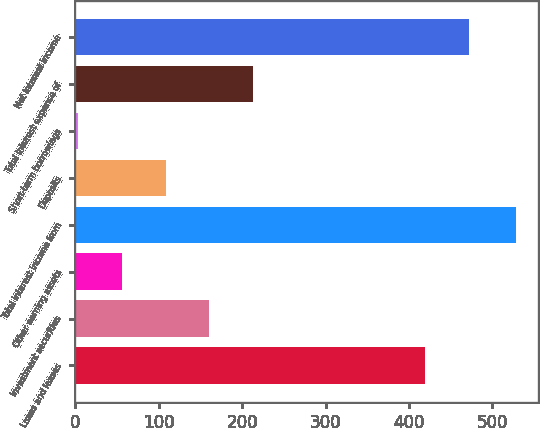<chart> <loc_0><loc_0><loc_500><loc_500><bar_chart><fcel>Loans and leases<fcel>Investment securities<fcel>Other earning assets<fcel>Total interest income from<fcel>Deposits<fcel>Short-term borrowings<fcel>Total interest expense of<fcel>Net interest income<nl><fcel>419.3<fcel>160.79<fcel>55.93<fcel>527.8<fcel>108.36<fcel>3.5<fcel>213.22<fcel>471.73<nl></chart> 